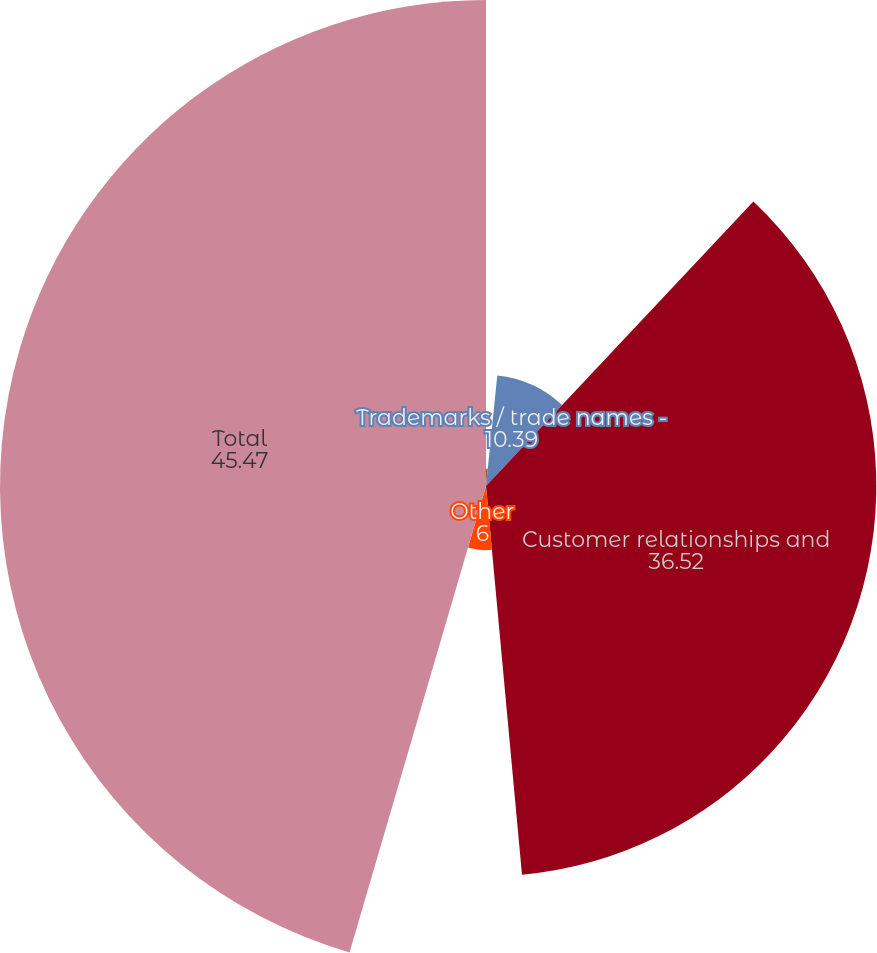<chart> <loc_0><loc_0><loc_500><loc_500><pie_chart><fcel>Non-compete agreements<fcel>Trademarks / trade names -<fcel>Customer relationships and<fcel>Other<fcel>Total<nl><fcel>1.62%<fcel>10.39%<fcel>36.52%<fcel>6.0%<fcel>45.47%<nl></chart> 